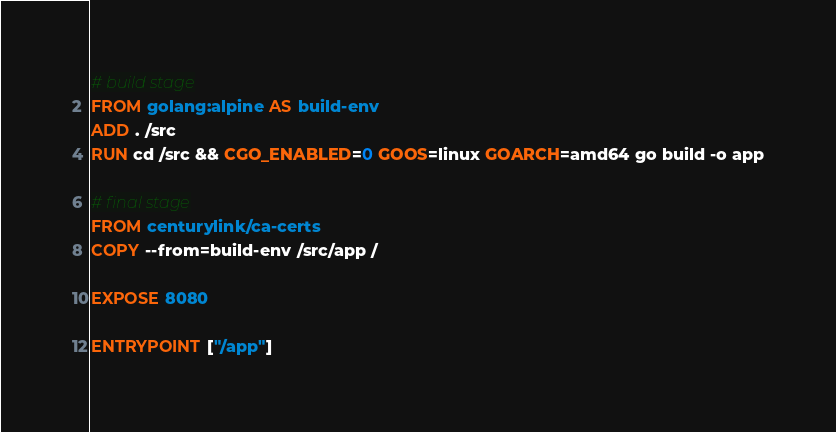<code> <loc_0><loc_0><loc_500><loc_500><_Dockerfile_># build stage
FROM golang:alpine AS build-env
ADD . /src
RUN cd /src && CGO_ENABLED=0 GOOS=linux GOARCH=amd64 go build -o app

# final stage
FROM centurylink/ca-certs
COPY --from=build-env /src/app /

EXPOSE 8080

ENTRYPOINT ["/app"]
</code> 